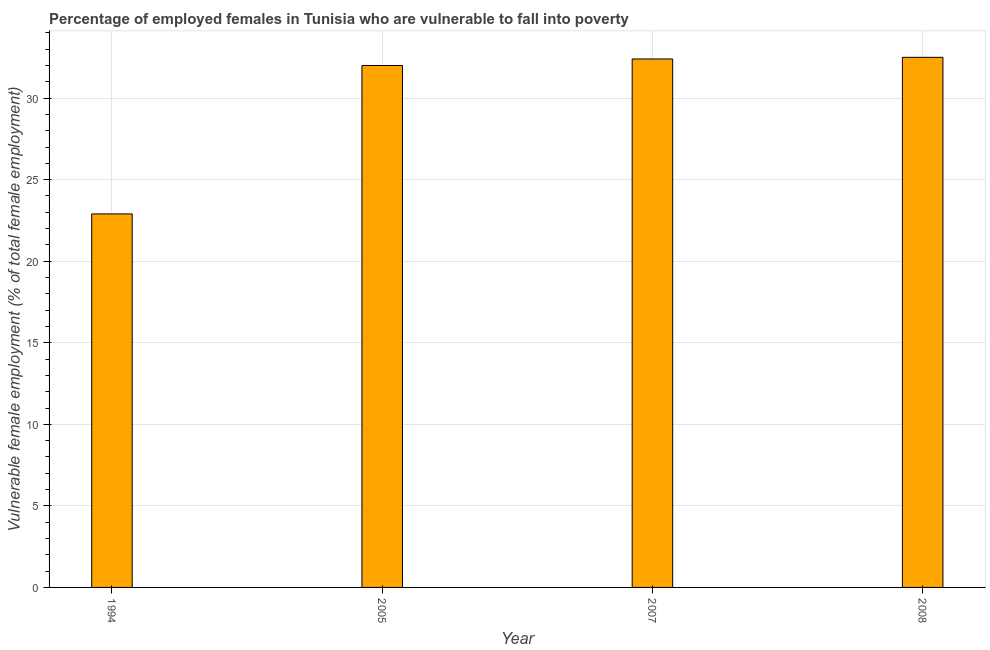Does the graph contain any zero values?
Give a very brief answer. No. Does the graph contain grids?
Offer a terse response. Yes. What is the title of the graph?
Offer a terse response. Percentage of employed females in Tunisia who are vulnerable to fall into poverty. What is the label or title of the X-axis?
Ensure brevity in your answer.  Year. What is the label or title of the Y-axis?
Offer a very short reply. Vulnerable female employment (% of total female employment). What is the percentage of employed females who are vulnerable to fall into poverty in 2007?
Offer a very short reply. 32.4. Across all years, what is the maximum percentage of employed females who are vulnerable to fall into poverty?
Your response must be concise. 32.5. Across all years, what is the minimum percentage of employed females who are vulnerable to fall into poverty?
Ensure brevity in your answer.  22.9. In which year was the percentage of employed females who are vulnerable to fall into poverty maximum?
Give a very brief answer. 2008. What is the sum of the percentage of employed females who are vulnerable to fall into poverty?
Offer a terse response. 119.8. What is the average percentage of employed females who are vulnerable to fall into poverty per year?
Provide a short and direct response. 29.95. What is the median percentage of employed females who are vulnerable to fall into poverty?
Offer a terse response. 32.2. In how many years, is the percentage of employed females who are vulnerable to fall into poverty greater than 26 %?
Make the answer very short. 3. What is the ratio of the percentage of employed females who are vulnerable to fall into poverty in 2007 to that in 2008?
Keep it short and to the point. 1. What is the difference between the highest and the second highest percentage of employed females who are vulnerable to fall into poverty?
Offer a terse response. 0.1. Are all the bars in the graph horizontal?
Your answer should be very brief. No. How many years are there in the graph?
Provide a short and direct response. 4. What is the difference between two consecutive major ticks on the Y-axis?
Provide a succinct answer. 5. Are the values on the major ticks of Y-axis written in scientific E-notation?
Your answer should be very brief. No. What is the Vulnerable female employment (% of total female employment) of 1994?
Offer a terse response. 22.9. What is the Vulnerable female employment (% of total female employment) in 2005?
Offer a terse response. 32. What is the Vulnerable female employment (% of total female employment) of 2007?
Provide a succinct answer. 32.4. What is the Vulnerable female employment (% of total female employment) of 2008?
Offer a terse response. 32.5. What is the difference between the Vulnerable female employment (% of total female employment) in 1994 and 2007?
Your answer should be compact. -9.5. What is the difference between the Vulnerable female employment (% of total female employment) in 1994 and 2008?
Ensure brevity in your answer.  -9.6. What is the ratio of the Vulnerable female employment (% of total female employment) in 1994 to that in 2005?
Provide a succinct answer. 0.72. What is the ratio of the Vulnerable female employment (% of total female employment) in 1994 to that in 2007?
Provide a succinct answer. 0.71. What is the ratio of the Vulnerable female employment (% of total female employment) in 1994 to that in 2008?
Keep it short and to the point. 0.7. What is the ratio of the Vulnerable female employment (% of total female employment) in 2005 to that in 2007?
Ensure brevity in your answer.  0.99. 